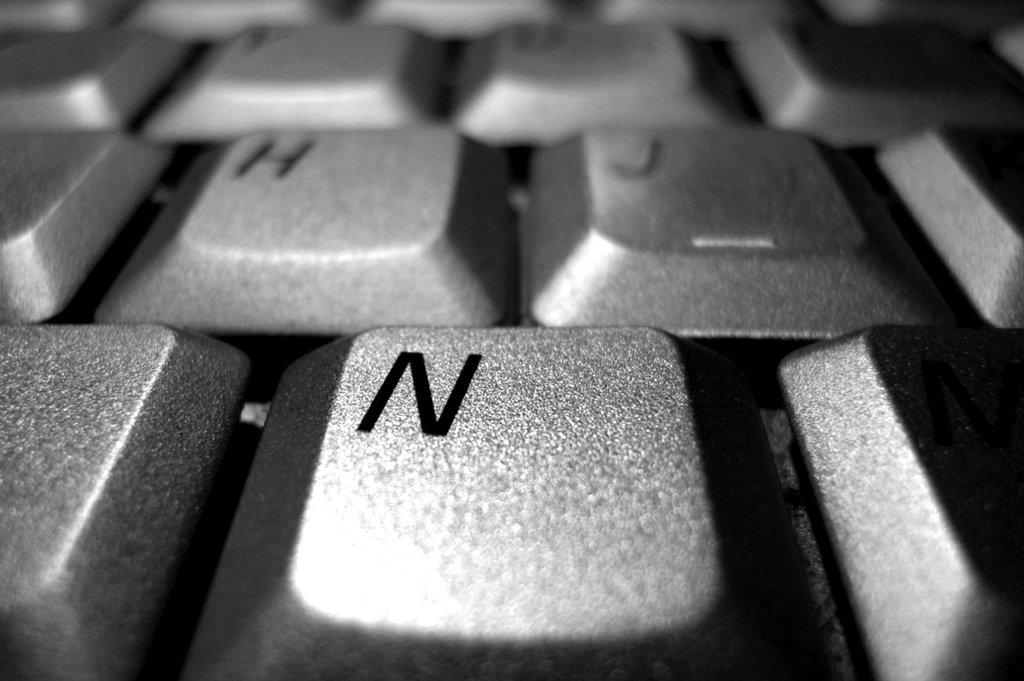<image>
Share a concise interpretation of the image provided. A black keyboard has H, J, and N, keys. 